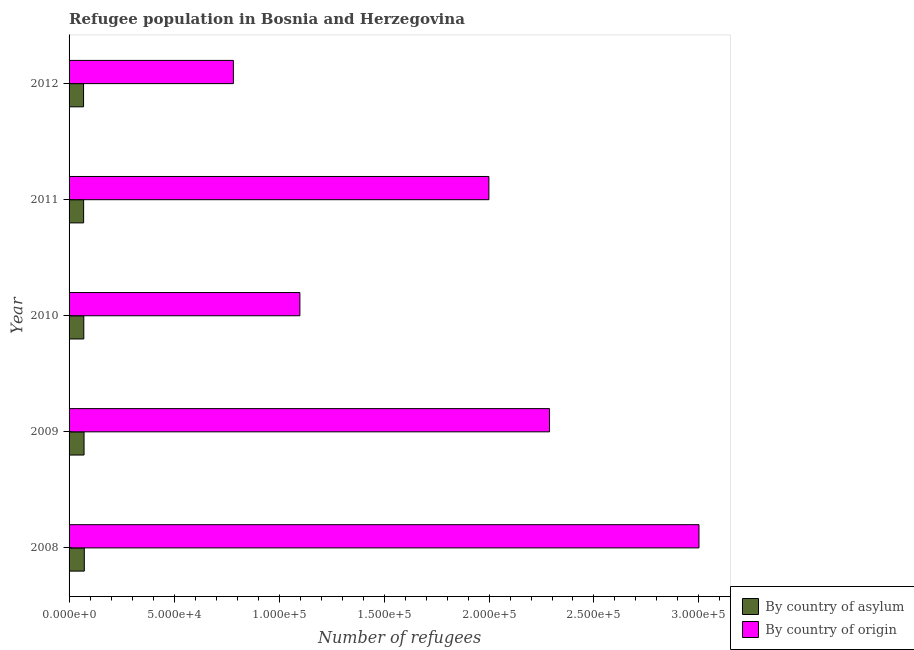How many groups of bars are there?
Offer a terse response. 5. Are the number of bars per tick equal to the number of legend labels?
Provide a succinct answer. Yes. Are the number of bars on each tick of the Y-axis equal?
Provide a short and direct response. Yes. How many bars are there on the 4th tick from the top?
Provide a short and direct response. 2. How many bars are there on the 3rd tick from the bottom?
Give a very brief answer. 2. In how many cases, is the number of bars for a given year not equal to the number of legend labels?
Offer a very short reply. 0. What is the number of refugees by country of asylum in 2009?
Your answer should be compact. 7132. Across all years, what is the maximum number of refugees by country of asylum?
Your answer should be compact. 7257. Across all years, what is the minimum number of refugees by country of asylum?
Keep it short and to the point. 6903. In which year was the number of refugees by country of origin maximum?
Provide a succinct answer. 2008. What is the total number of refugees by country of origin in the graph?
Provide a succinct answer. 9.17e+05. What is the difference between the number of refugees by country of asylum in 2009 and that in 2010?
Offer a very short reply. 116. What is the difference between the number of refugees by country of origin in 2010 and the number of refugees by country of asylum in 2012?
Make the answer very short. 1.03e+05. What is the average number of refugees by country of asylum per year?
Provide a short and direct response. 7048.2. In the year 2009, what is the difference between the number of refugees by country of origin and number of refugees by country of asylum?
Offer a terse response. 2.22e+05. Is the difference between the number of refugees by country of asylum in 2010 and 2012 greater than the difference between the number of refugees by country of origin in 2010 and 2012?
Your answer should be compact. No. What is the difference between the highest and the second highest number of refugees by country of origin?
Provide a succinct answer. 7.12e+04. What is the difference between the highest and the lowest number of refugees by country of asylum?
Keep it short and to the point. 354. Is the sum of the number of refugees by country of asylum in 2008 and 2011 greater than the maximum number of refugees by country of origin across all years?
Keep it short and to the point. No. What does the 1st bar from the top in 2011 represents?
Give a very brief answer. By country of origin. What does the 1st bar from the bottom in 2010 represents?
Offer a very short reply. By country of asylum. What is the difference between two consecutive major ticks on the X-axis?
Your answer should be very brief. 5.00e+04. Does the graph contain grids?
Make the answer very short. No. How many legend labels are there?
Ensure brevity in your answer.  2. How are the legend labels stacked?
Give a very brief answer. Vertical. What is the title of the graph?
Provide a succinct answer. Refugee population in Bosnia and Herzegovina. What is the label or title of the X-axis?
Your response must be concise. Number of refugees. What is the label or title of the Y-axis?
Offer a terse response. Year. What is the Number of refugees in By country of asylum in 2008?
Make the answer very short. 7257. What is the Number of refugees in By country of origin in 2008?
Ensure brevity in your answer.  3.00e+05. What is the Number of refugees of By country of asylum in 2009?
Keep it short and to the point. 7132. What is the Number of refugees in By country of origin in 2009?
Your answer should be compact. 2.29e+05. What is the Number of refugees in By country of asylum in 2010?
Make the answer very short. 7016. What is the Number of refugees in By country of origin in 2010?
Keep it short and to the point. 1.10e+05. What is the Number of refugees in By country of asylum in 2011?
Your answer should be very brief. 6933. What is the Number of refugees of By country of origin in 2011?
Offer a very short reply. 2.00e+05. What is the Number of refugees in By country of asylum in 2012?
Offer a terse response. 6903. What is the Number of refugees of By country of origin in 2012?
Ensure brevity in your answer.  7.83e+04. Across all years, what is the maximum Number of refugees in By country of asylum?
Offer a very short reply. 7257. Across all years, what is the maximum Number of refugees in By country of origin?
Offer a very short reply. 3.00e+05. Across all years, what is the minimum Number of refugees in By country of asylum?
Your answer should be compact. 6903. Across all years, what is the minimum Number of refugees of By country of origin?
Provide a succinct answer. 7.83e+04. What is the total Number of refugees in By country of asylum in the graph?
Your answer should be compact. 3.52e+04. What is the total Number of refugees of By country of origin in the graph?
Make the answer very short. 9.17e+05. What is the difference between the Number of refugees of By country of asylum in 2008 and that in 2009?
Provide a succinct answer. 125. What is the difference between the Number of refugees in By country of origin in 2008 and that in 2009?
Your answer should be compact. 7.12e+04. What is the difference between the Number of refugees in By country of asylum in 2008 and that in 2010?
Offer a terse response. 241. What is the difference between the Number of refugees of By country of origin in 2008 and that in 2010?
Your answer should be compact. 1.90e+05. What is the difference between the Number of refugees in By country of asylum in 2008 and that in 2011?
Provide a short and direct response. 324. What is the difference between the Number of refugees in By country of origin in 2008 and that in 2011?
Offer a terse response. 1.00e+05. What is the difference between the Number of refugees in By country of asylum in 2008 and that in 2012?
Your response must be concise. 354. What is the difference between the Number of refugees of By country of origin in 2008 and that in 2012?
Your response must be concise. 2.22e+05. What is the difference between the Number of refugees of By country of asylum in 2009 and that in 2010?
Your answer should be very brief. 116. What is the difference between the Number of refugees of By country of origin in 2009 and that in 2010?
Make the answer very short. 1.19e+05. What is the difference between the Number of refugees in By country of asylum in 2009 and that in 2011?
Give a very brief answer. 199. What is the difference between the Number of refugees of By country of origin in 2009 and that in 2011?
Make the answer very short. 2.89e+04. What is the difference between the Number of refugees of By country of asylum in 2009 and that in 2012?
Give a very brief answer. 229. What is the difference between the Number of refugees in By country of origin in 2009 and that in 2012?
Give a very brief answer. 1.51e+05. What is the difference between the Number of refugees of By country of origin in 2010 and that in 2011?
Provide a short and direct response. -9.00e+04. What is the difference between the Number of refugees of By country of asylum in 2010 and that in 2012?
Make the answer very short. 113. What is the difference between the Number of refugees in By country of origin in 2010 and that in 2012?
Offer a very short reply. 3.17e+04. What is the difference between the Number of refugees in By country of asylum in 2011 and that in 2012?
Your answer should be compact. 30. What is the difference between the Number of refugees in By country of origin in 2011 and that in 2012?
Make the answer very short. 1.22e+05. What is the difference between the Number of refugees in By country of asylum in 2008 and the Number of refugees in By country of origin in 2009?
Your answer should be compact. -2.22e+05. What is the difference between the Number of refugees in By country of asylum in 2008 and the Number of refugees in By country of origin in 2010?
Make the answer very short. -1.03e+05. What is the difference between the Number of refugees of By country of asylum in 2008 and the Number of refugees of By country of origin in 2011?
Offer a very short reply. -1.93e+05. What is the difference between the Number of refugees of By country of asylum in 2008 and the Number of refugees of By country of origin in 2012?
Provide a short and direct response. -7.10e+04. What is the difference between the Number of refugees of By country of asylum in 2009 and the Number of refugees of By country of origin in 2010?
Provide a short and direct response. -1.03e+05. What is the difference between the Number of refugees in By country of asylum in 2009 and the Number of refugees in By country of origin in 2011?
Ensure brevity in your answer.  -1.93e+05. What is the difference between the Number of refugees of By country of asylum in 2009 and the Number of refugees of By country of origin in 2012?
Your answer should be very brief. -7.11e+04. What is the difference between the Number of refugees of By country of asylum in 2010 and the Number of refugees of By country of origin in 2011?
Make the answer very short. -1.93e+05. What is the difference between the Number of refugees of By country of asylum in 2010 and the Number of refugees of By country of origin in 2012?
Ensure brevity in your answer.  -7.13e+04. What is the difference between the Number of refugees of By country of asylum in 2011 and the Number of refugees of By country of origin in 2012?
Give a very brief answer. -7.13e+04. What is the average Number of refugees of By country of asylum per year?
Give a very brief answer. 7048.2. What is the average Number of refugees in By country of origin per year?
Your response must be concise. 1.83e+05. In the year 2008, what is the difference between the Number of refugees in By country of asylum and Number of refugees in By country of origin?
Ensure brevity in your answer.  -2.93e+05. In the year 2009, what is the difference between the Number of refugees in By country of asylum and Number of refugees in By country of origin?
Make the answer very short. -2.22e+05. In the year 2010, what is the difference between the Number of refugees in By country of asylum and Number of refugees in By country of origin?
Your response must be concise. -1.03e+05. In the year 2011, what is the difference between the Number of refugees in By country of asylum and Number of refugees in By country of origin?
Provide a succinct answer. -1.93e+05. In the year 2012, what is the difference between the Number of refugees in By country of asylum and Number of refugees in By country of origin?
Offer a very short reply. -7.14e+04. What is the ratio of the Number of refugees in By country of asylum in 2008 to that in 2009?
Your answer should be very brief. 1.02. What is the ratio of the Number of refugees of By country of origin in 2008 to that in 2009?
Offer a terse response. 1.31. What is the ratio of the Number of refugees in By country of asylum in 2008 to that in 2010?
Offer a terse response. 1.03. What is the ratio of the Number of refugees in By country of origin in 2008 to that in 2010?
Make the answer very short. 2.73. What is the ratio of the Number of refugees of By country of asylum in 2008 to that in 2011?
Keep it short and to the point. 1.05. What is the ratio of the Number of refugees of By country of origin in 2008 to that in 2011?
Ensure brevity in your answer.  1.5. What is the ratio of the Number of refugees in By country of asylum in 2008 to that in 2012?
Your response must be concise. 1.05. What is the ratio of the Number of refugees of By country of origin in 2008 to that in 2012?
Provide a short and direct response. 3.83. What is the ratio of the Number of refugees in By country of asylum in 2009 to that in 2010?
Your answer should be very brief. 1.02. What is the ratio of the Number of refugees in By country of origin in 2009 to that in 2010?
Your answer should be very brief. 2.08. What is the ratio of the Number of refugees of By country of asylum in 2009 to that in 2011?
Your answer should be compact. 1.03. What is the ratio of the Number of refugees of By country of origin in 2009 to that in 2011?
Keep it short and to the point. 1.14. What is the ratio of the Number of refugees in By country of asylum in 2009 to that in 2012?
Make the answer very short. 1.03. What is the ratio of the Number of refugees in By country of origin in 2009 to that in 2012?
Provide a succinct answer. 2.92. What is the ratio of the Number of refugees in By country of origin in 2010 to that in 2011?
Provide a short and direct response. 0.55. What is the ratio of the Number of refugees in By country of asylum in 2010 to that in 2012?
Your response must be concise. 1.02. What is the ratio of the Number of refugees of By country of origin in 2010 to that in 2012?
Your answer should be compact. 1.4. What is the ratio of the Number of refugees in By country of asylum in 2011 to that in 2012?
Provide a succinct answer. 1. What is the ratio of the Number of refugees in By country of origin in 2011 to that in 2012?
Make the answer very short. 2.55. What is the difference between the highest and the second highest Number of refugees in By country of asylum?
Provide a succinct answer. 125. What is the difference between the highest and the second highest Number of refugees in By country of origin?
Provide a short and direct response. 7.12e+04. What is the difference between the highest and the lowest Number of refugees of By country of asylum?
Ensure brevity in your answer.  354. What is the difference between the highest and the lowest Number of refugees in By country of origin?
Give a very brief answer. 2.22e+05. 